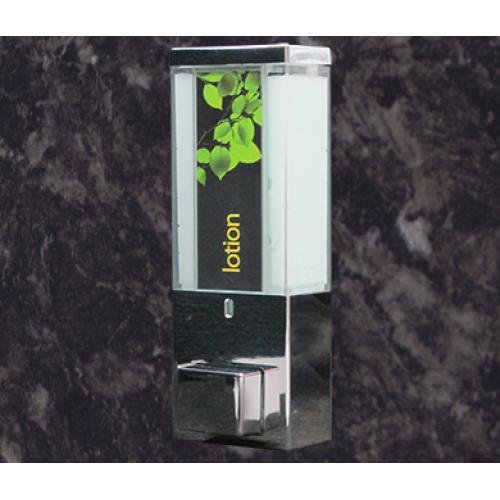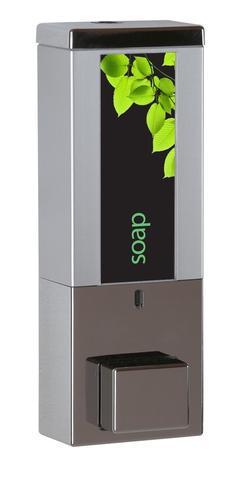The first image is the image on the left, the second image is the image on the right. Assess this claim about the two images: "The left image contains both a shampoo container and a body wash container.". Correct or not? Answer yes or no. No. The first image is the image on the left, the second image is the image on the right. Analyze the images presented: Is the assertion "There are more dispensers in the right image than in the left image." valid? Answer yes or no. No. 